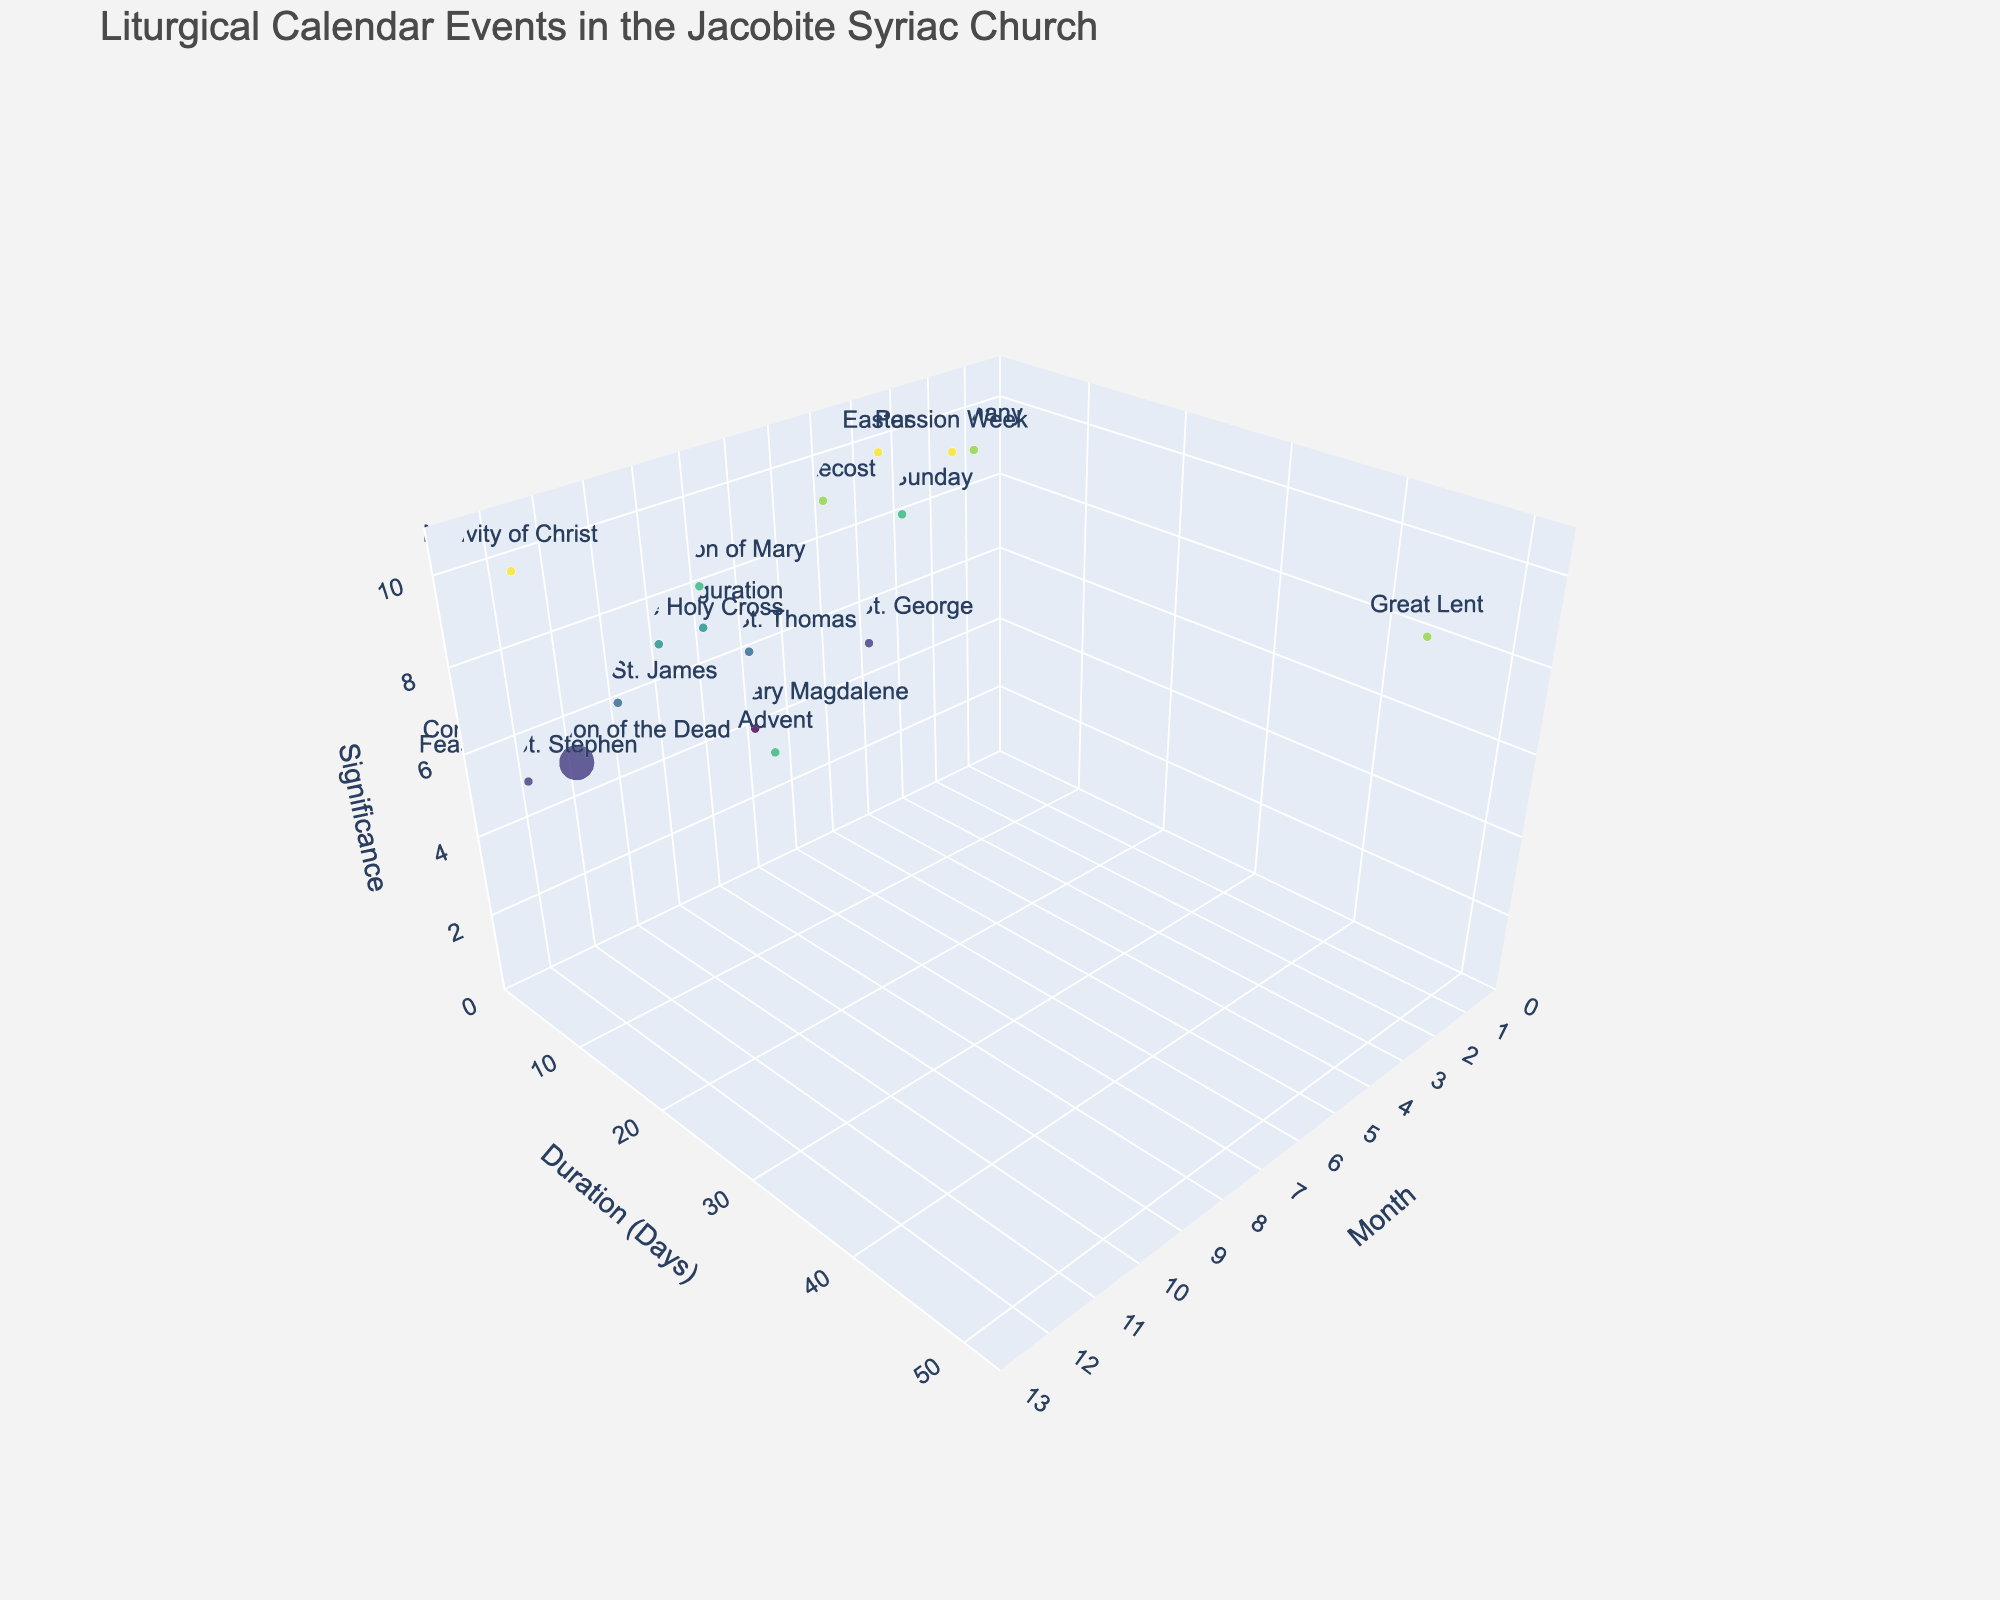what's the title of the plot? The title of the plot is located at the top of the figure and provides an overview of what's being displayed, which is "Liturgical Calendar Events in the Jacobite Syriac Church".
Answer: Liturgical Calendar Events in the Jacobite Syriac Church Which event has the longest duration? Look at the y-axis labeled "Duration (Days)" and find the event with the highest value on this axis. According to the figure, "Great Lent" has the longest duration of 48 days.
Answer: Great Lent What month has the most events on the plot? Count the number of events plotted for each month along the x-axis. November has more events plotted than any other month.
Answer: November Which event is both highly significant and of long duration? Look for events with high values on the z-axis (Significance) and high values on the y-axis (Duration). The "Great Lent" with a duration of 48 days and high significance of 9, stands out.
Answer: Great Lent How many events are there in the month of April? Identify the x-axis value for April (4) and count the number of events plotted in that month. There are two events: "Easter" and "Feast of St. George."
Answer: Two Which events occur in December? Find the points in the plot corresponding to the x-axis value of 12. The events are "Nativity of Christ" and "Feast of St. Stephen".
Answer: Nativity of Christ, Feast of St. Stephen Which event is depicted as having the highest significance while happening in the shortest duration? Look for a point near the top of the z-axis (high significance) and near the bottom of the y-axis (short duration). "Epiphany" occurs in January with a significance of 9 and duration of 1 day.
Answer: Epiphany Differentiate between the significance of "Feast of St. George" and "Feast of St. James." Compare their positions on the z-axis. "Feast of St. George" has a significance of 5, whereas "Feast of St. James" has a significance of 6.
Answer: Feast of St. James has higher significance How does the frequency of "Commemoration of the Dead" compare to that of "Easter"? Check the sizes of the markers representing these events. "Commemoration of the Dead" occurs 4 times a year, while "Easter" occurs once.
Answer: Commemoration of the Dead is more frequent Which event in August has a higher significance, "Transfiguration" or "Assumption of Mary"? Compare the heights of these markers along the z-axis within the month of August (x-axis value of 8). "Assumption of Mary" has a significance of 8, while "Transfiguration" has a significance of 7.
Answer: Assumption of Mary 